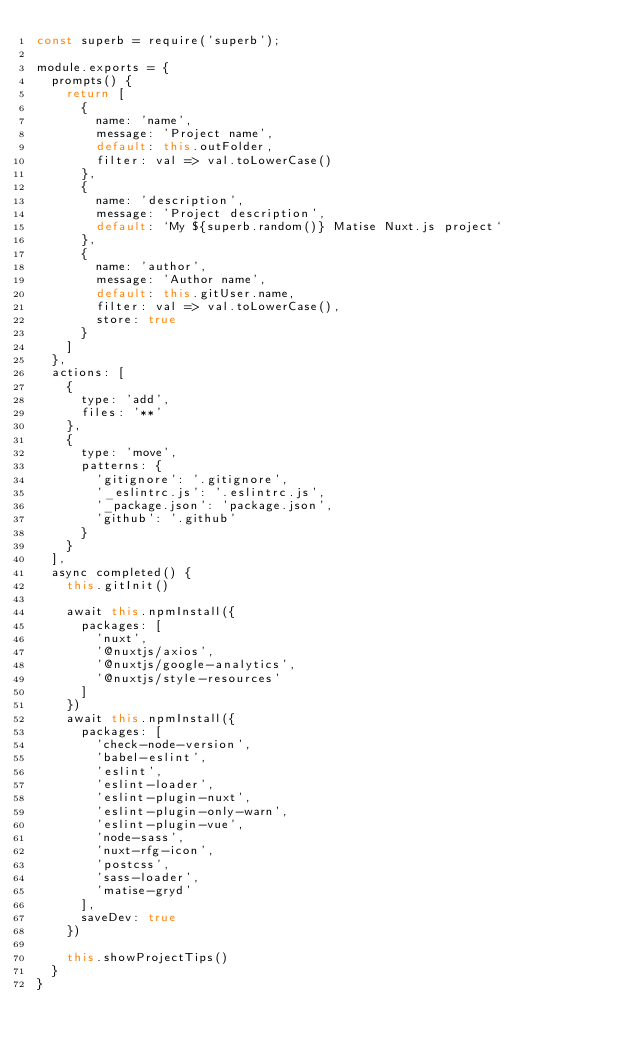Convert code to text. <code><loc_0><loc_0><loc_500><loc_500><_JavaScript_>const superb = require('superb');

module.exports = {
	prompts() {
		return [
			{
				name: 'name',
				message: 'Project name',
				default: this.outFolder,
				filter: val => val.toLowerCase()
			},
			{
				name: 'description',
				message: 'Project description',
				default: `My ${superb.random()} Matise Nuxt.js project`
			},
			{
				name: 'author',
				message: 'Author name',
				default: this.gitUser.name,
				filter: val => val.toLowerCase(),
				store: true
			}
		]
	},
	actions: [
		{
			type: 'add',
			files: '**'
		},
		{
			type: 'move',
			patterns: {
				'gitignore': '.gitignore',
				'_eslintrc.js': '.eslintrc.js',
				'_package.json': 'package.json',
				'github': '.github'
			}
		}
	],
	async completed() {
		this.gitInit()

		await this.npmInstall({
			packages: [
				'nuxt',
				'@nuxtjs/axios',
				'@nuxtjs/google-analytics',
				'@nuxtjs/style-resources'
			]
		})
		await this.npmInstall({
			packages: [
				'check-node-version',
				'babel-eslint',
				'eslint',
				'eslint-loader',
				'eslint-plugin-nuxt',
				'eslint-plugin-only-warn',
				'eslint-plugin-vue',
				'node-sass',
				'nuxt-rfg-icon',
				'postcss',
				'sass-loader',
				'matise-gryd'
			],
			saveDev: true
		})

		this.showProjectTips()
	}
}
</code> 